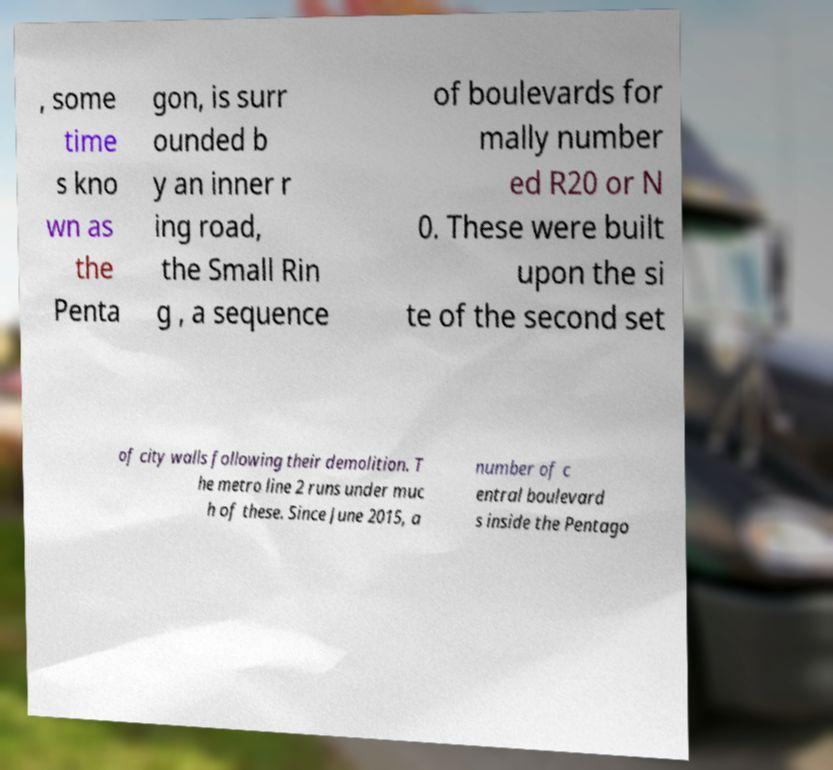What messages or text are displayed in this image? I need them in a readable, typed format. , some time s kno wn as the Penta gon, is surr ounded b y an inner r ing road, the Small Rin g , a sequence of boulevards for mally number ed R20 or N 0. These were built upon the si te of the second set of city walls following their demolition. T he metro line 2 runs under muc h of these. Since June 2015, a number of c entral boulevard s inside the Pentago 